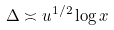Convert formula to latex. <formula><loc_0><loc_0><loc_500><loc_500>\Delta \asymp u ^ { 1 / 2 } \log x</formula> 